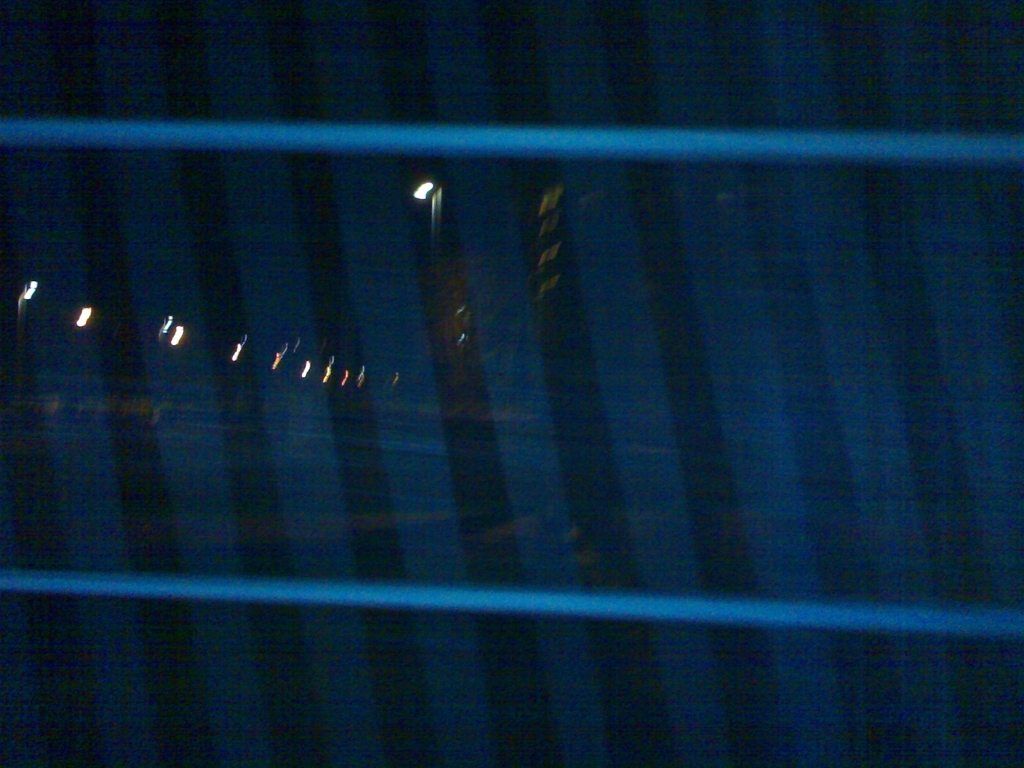Does the image have a good balance of light and shadow? The image depicts a low-light scene with a streak of artificial lights, possibly streetlights, creating high contrast against the dark environment. However, the overall composition and the excessive darkness suggest a lack of balance in the distribution of light and shadow, leading to a predominance of shadow. This imbalance might be intentional or a result of the conditions under which the photo was taken; without additional information, it's challenging to determine if the effect was deliberate. 